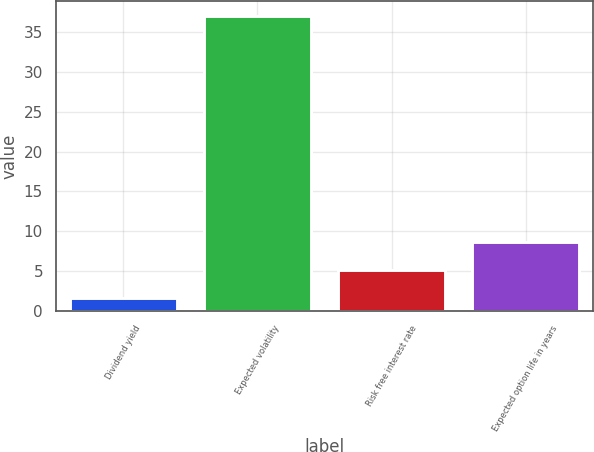Convert chart. <chart><loc_0><loc_0><loc_500><loc_500><bar_chart><fcel>Dividend yield<fcel>Expected volatility<fcel>Risk free interest rate<fcel>Expected option life in years<nl><fcel>1.6<fcel>37<fcel>5.14<fcel>8.68<nl></chart> 